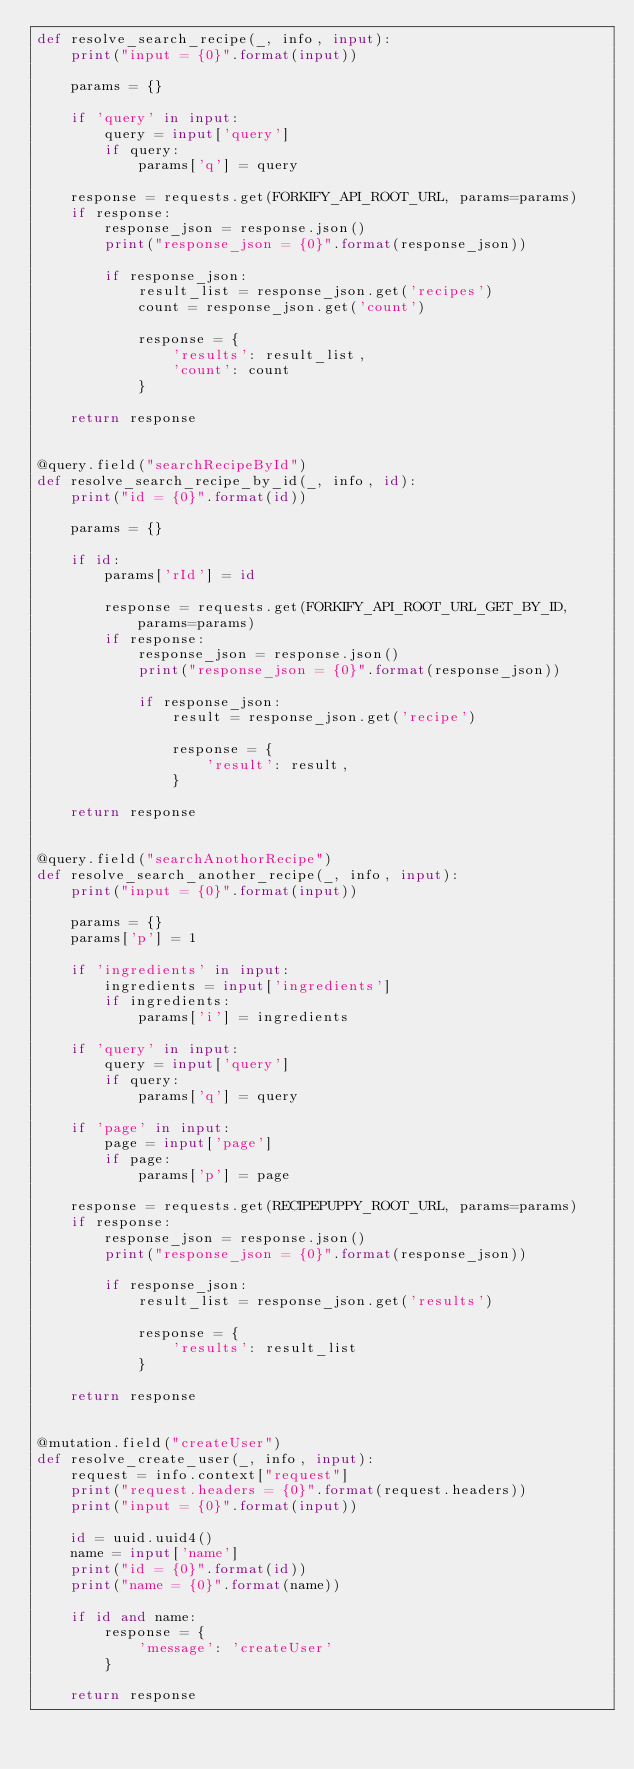Convert code to text. <code><loc_0><loc_0><loc_500><loc_500><_Python_>def resolve_search_recipe(_, info, input):
    print("input = {0}".format(input))

    params = {}

    if 'query' in input:
        query = input['query']
        if query:
            params['q'] = query

    response = requests.get(FORKIFY_API_ROOT_URL, params=params)
    if response:
        response_json = response.json()
        print("response_json = {0}".format(response_json))

        if response_json:
            result_list = response_json.get('recipes')
            count = response_json.get('count')

            response = {
                'results': result_list,
                'count': count
            }

    return response


@query.field("searchRecipeById")
def resolve_search_recipe_by_id(_, info, id):
    print("id = {0}".format(id))

    params = {}

    if id:
        params['rId'] = id

        response = requests.get(FORKIFY_API_ROOT_URL_GET_BY_ID, params=params)
        if response:
            response_json = response.json()
            print("response_json = {0}".format(response_json))

            if response_json:
                result = response_json.get('recipe')

                response = {
                    'result': result,
                }

    return response


@query.field("searchAnothorRecipe")
def resolve_search_another_recipe(_, info, input):
    print("input = {0}".format(input))

    params = {}
    params['p'] = 1

    if 'ingredients' in input:
        ingredients = input['ingredients']
        if ingredients:
            params['i'] = ingredients

    if 'query' in input:
        query = input['query']
        if query:
            params['q'] = query

    if 'page' in input:
        page = input['page']
        if page:
            params['p'] = page

    response = requests.get(RECIPEPUPPY_ROOT_URL, params=params)
    if response:
        response_json = response.json()
        print("response_json = {0}".format(response_json))

        if response_json:
            result_list = response_json.get('results')

            response = {
                'results': result_list
            }

    return response


@mutation.field("createUser")
def resolve_create_user(_, info, input):
    request = info.context["request"]
    print("request.headers = {0}".format(request.headers))
    print("input = {0}".format(input))

    id = uuid.uuid4()
    name = input['name']
    print("id = {0}".format(id))
    print("name = {0}".format(name))

    if id and name:
        response = {
            'message': 'createUser'
        }

    return response
</code> 